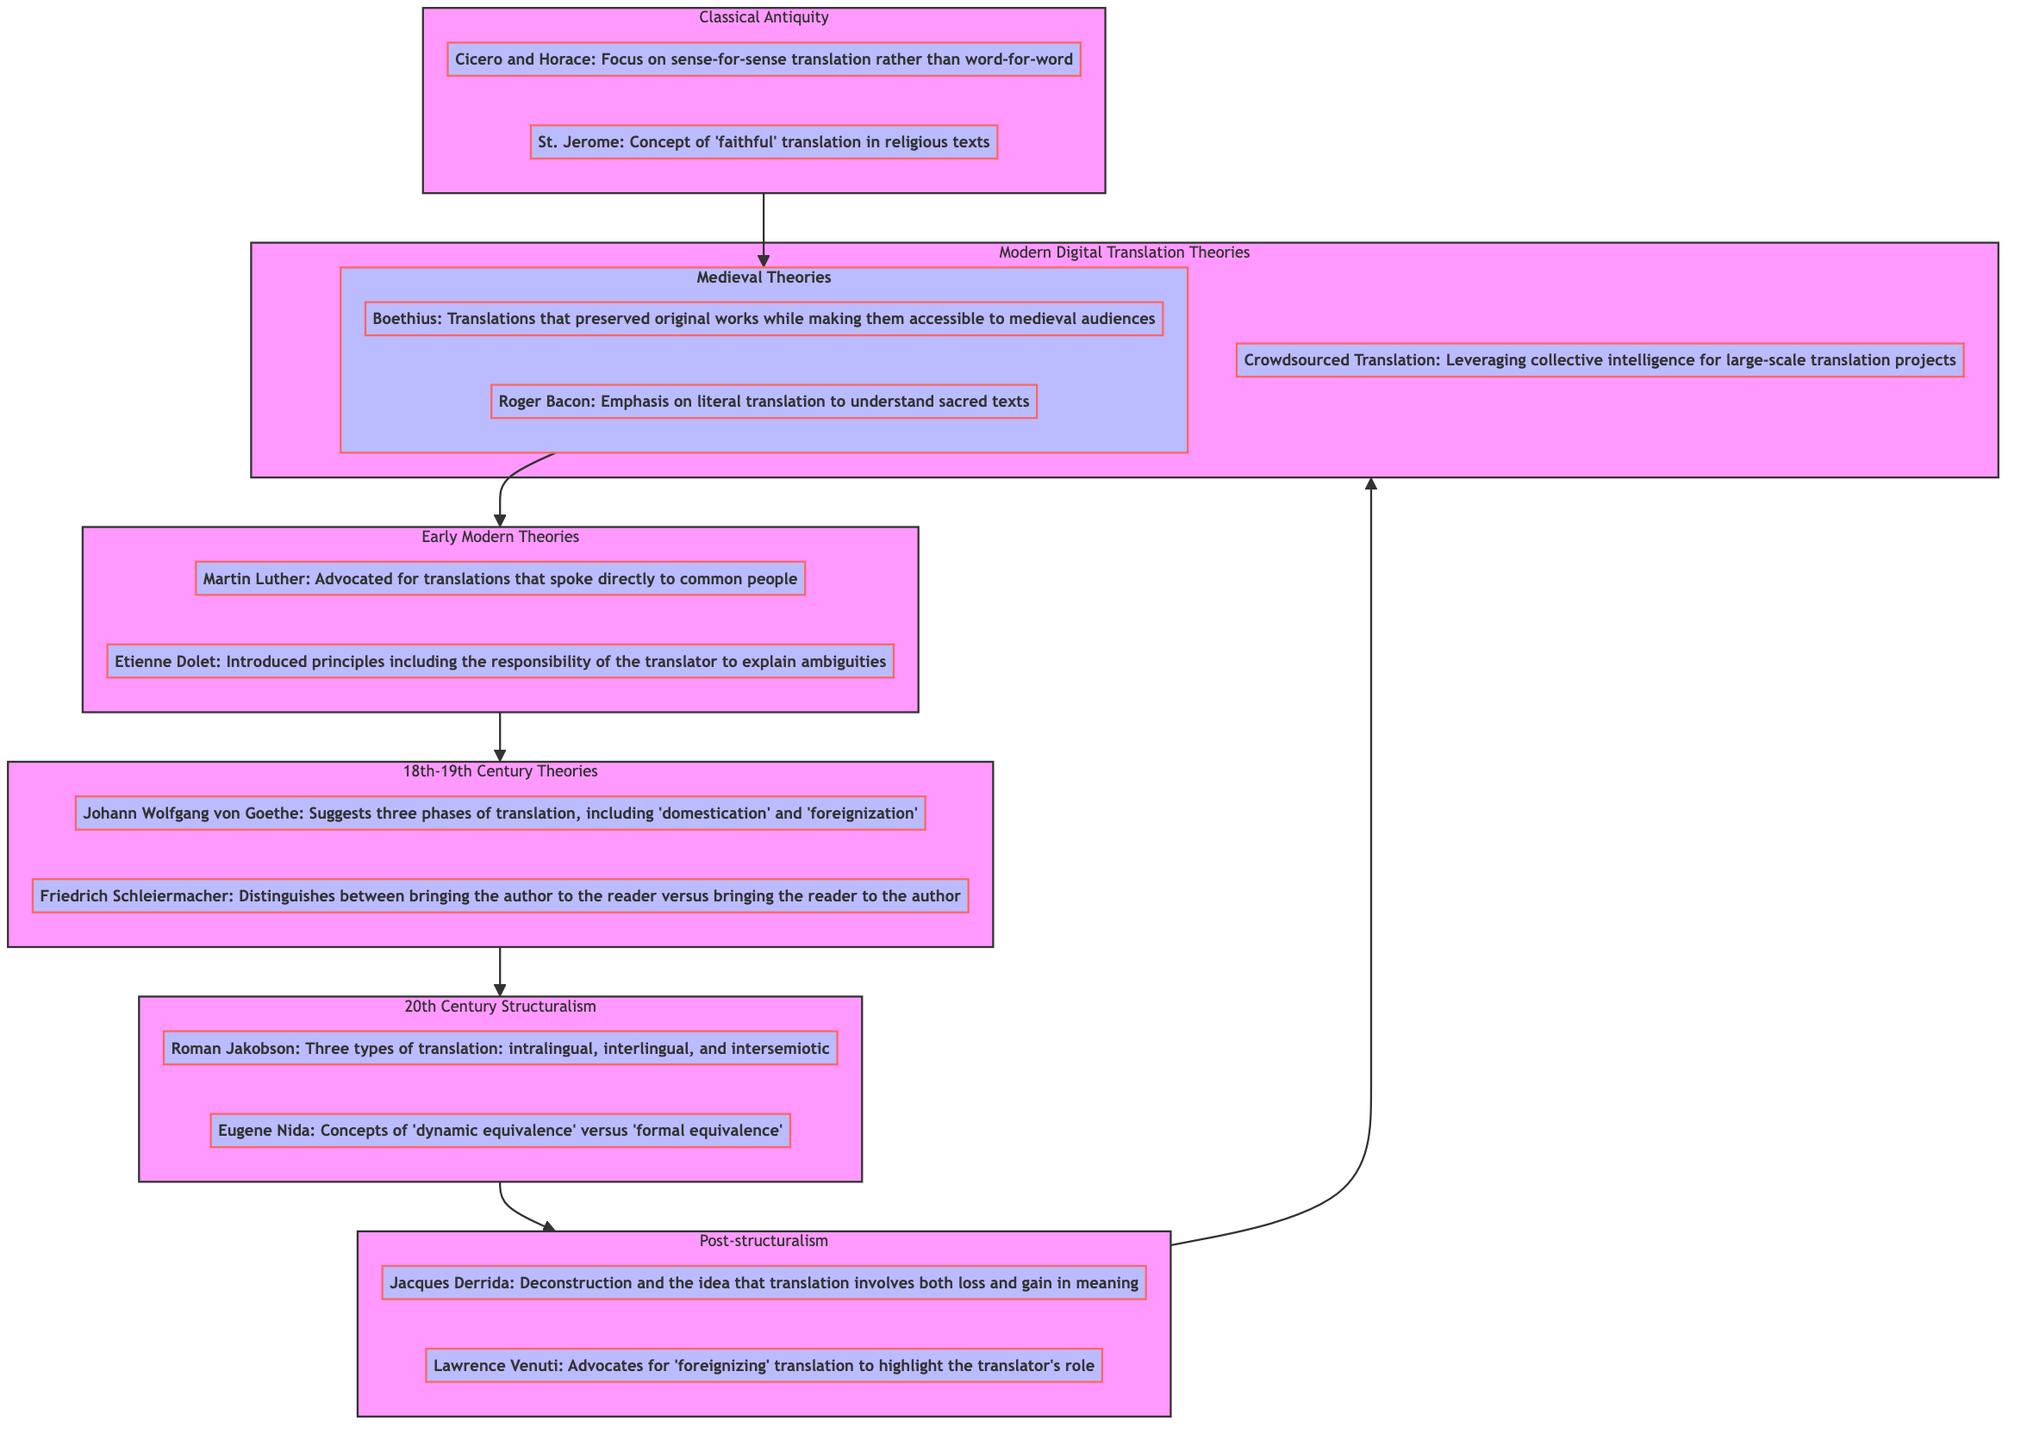What is the period at the top of the flow chart? The flow chart progresses from the bottom of Classical Antiquity to the top of Modern Digital Translation Theories, with the latter being the highest period depicted.
Answer: Modern Digital Translation Theories How many theories are listed under "18th-19th Century Theories"? The node for "18th-19th Century Theories" contains two theories, namely Johann Wolfgang von Goethe and Friedrich Schleiermacher, each described with distinct contributions to translation theory.
Answer: 2 What is the relationship between "Post-structuralism" and "20th Century Structuralism"? "Post-structuralism" is directly above "20th Century Structuralism" in the flow chart, indicating that it is a subsequent phase in the evolution of translation theories represented in the diagram.
Answer: Above Who advocated for “literal translation” in the Medieval Theories? The Medieval Theories section names Roger Bacon, who focused on the importance of literal translation to fully understand sacred texts, making him the identifiable advocate for this approach.
Answer: Roger Bacon Which theory suggests the translator’s responsibility to explain ambiguities? The theory by Etienne Dolet within the Early Modern Theories highlights the translator's obligation to clarify ambiguities, illustrating his approach to translation work.
Answer: Etienne Dolet How many total periods are represented in this flow chart? Counting the nodes from the flow chart, we have seven distinct periods listed, starting from Classical Antiquity and finishing at Modern Digital Translation Theories.
Answer: 7 What concept was introduced by Roman Jakobson in the 20th Century Structuralism? Roman Jakobson is noted in the flow chart for providing the three types of translation, categorized as intralingual, interlingual, and intersemiotic, thus showcasing a significant concept he introduced into translation theory.
Answer: Three types of translation Which theorist is associated with "faithful" translation in religious texts? In the period of Classical Antiquity, St. Jerome is recognized for his concept of "faithful" translation, particularly pertinent to religious literature and texts.
Answer: St. Jerome What is the key notion that defines the translation approach of Jacques Derrida? Jacques Derrida brings forth the idea of deconstruction, which emphasizes the inherent complexities in translation, particularly focusing on the dual aspects of loss and gain in meaning.
Answer: Deconstruction 